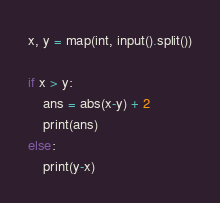<code> <loc_0><loc_0><loc_500><loc_500><_Python_>x, y = map(int, input().split())

if x > y:
    ans = abs(x-y) + 2
    print(ans)
else:
    print(y-x)</code> 